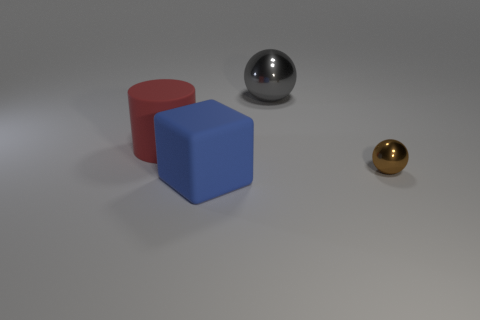The large metallic object that is the same shape as the tiny brown shiny object is what color?
Your answer should be compact. Gray. How many things are matte objects in front of the large red matte object or big things that are to the right of the matte block?
Your answer should be compact. 2. The tiny thing is what shape?
Provide a short and direct response. Sphere. How many blue objects are the same material as the small brown object?
Offer a terse response. 0. The big matte cube has what color?
Offer a terse response. Blue. The cylinder that is the same size as the gray metal ball is what color?
Your response must be concise. Red. Is there a rubber thing of the same color as the large sphere?
Your answer should be very brief. No. There is a metallic thing that is to the right of the large gray object; is its shape the same as the big thing to the right of the blue thing?
Provide a succinct answer. Yes. What number of other objects are the same size as the blue matte cube?
Give a very brief answer. 2. Are there fewer big blue blocks behind the rubber block than metal balls on the left side of the brown shiny object?
Ensure brevity in your answer.  Yes. 